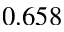<formula> <loc_0><loc_0><loc_500><loc_500>0 . 6 5 8</formula> 